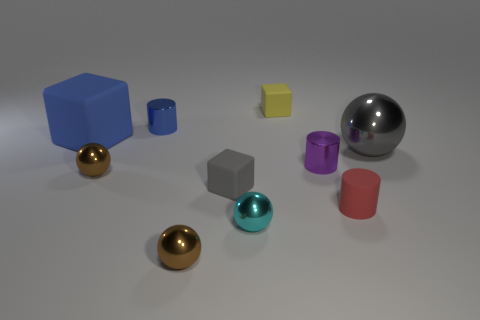What shape is the thing that is the same color as the big ball?
Offer a very short reply. Cube. The brown thing on the left side of the small metallic cylinder behind the shiny cylinder right of the small yellow thing is made of what material?
Your answer should be compact. Metal. Does the metal thing to the right of the tiny purple metallic object have the same shape as the blue matte object?
Offer a terse response. No. There is a big object on the right side of the big blue matte block; what material is it?
Provide a succinct answer. Metal. What number of rubber objects are either spheres or objects?
Offer a terse response. 4. Is there a purple matte thing that has the same size as the blue metal cylinder?
Keep it short and to the point. No. Are there more small purple shiny cylinders that are behind the yellow cube than metal blocks?
Give a very brief answer. No. How many big objects are either blue shiny things or cyan balls?
Provide a short and direct response. 0. How many other big matte objects are the same shape as the cyan object?
Ensure brevity in your answer.  0. What is the material of the tiny block that is in front of the tiny purple shiny object left of the red rubber object?
Provide a succinct answer. Rubber. 